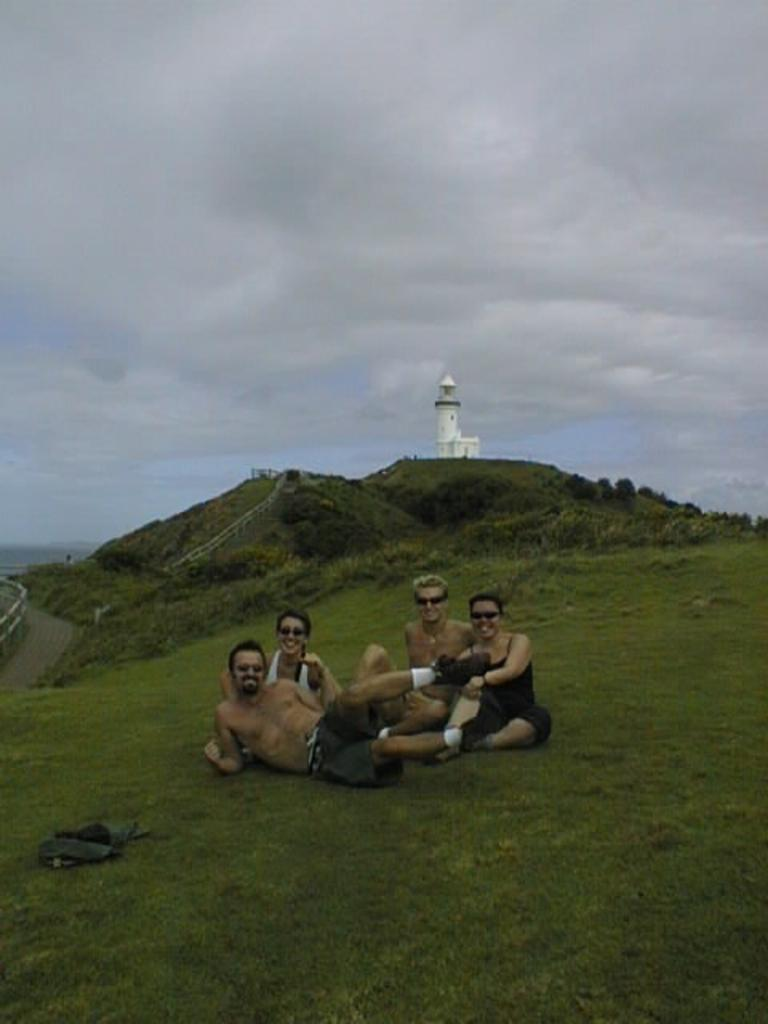How many people are in the image? There is a group of people in the image. What are the people doing in the image? The people are sitting in the grass. What can be seen in the background of the image? There is a building, trees, and a hill in the background of the image. What type of drum is being played by the people in the image? There is no drum present in the image; the people are sitting in the grass. 